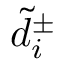<formula> <loc_0><loc_0><loc_500><loc_500>\tilde { d } _ { i } ^ { \pm }</formula> 